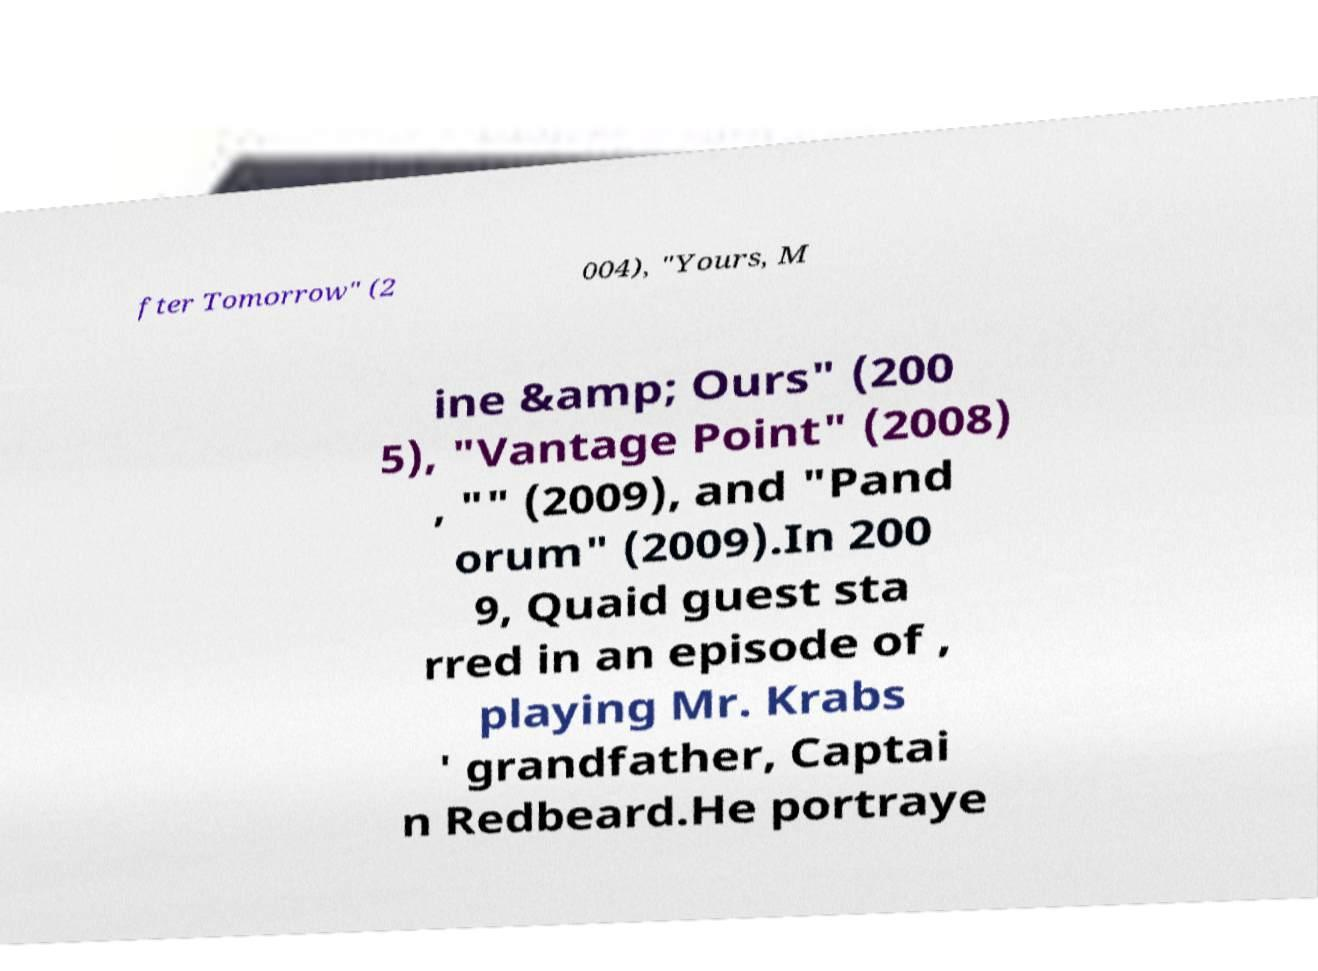What messages or text are displayed in this image? I need them in a readable, typed format. fter Tomorrow" (2 004), "Yours, M ine &amp; Ours" (200 5), "Vantage Point" (2008) , "" (2009), and "Pand orum" (2009).In 200 9, Quaid guest sta rred in an episode of , playing Mr. Krabs ' grandfather, Captai n Redbeard.He portraye 